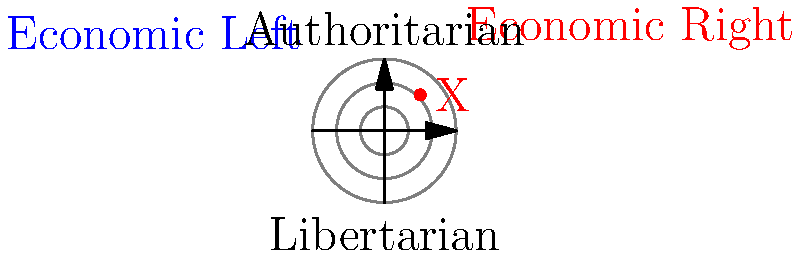In the political ideology spectrum represented by concentric circles in polar coordinates, a politician's stance is marked as point X. Which quadrant does this politician's ideology fall into, and what does it generally represent in terms of economic and social policies? To answer this question, we need to analyze the position of point X in the given polar coordinate system:

1. The diagram shows a political ideology spectrum with two axes:
   - Horizontal axis: Economic Left (negative) to Economic Right (positive)
   - Vertical axis: Libertarian (negative) to Authoritarian (positive)

2. The concentric circles represent different degrees of intensity, with the outer circles indicating stronger ideological leanings.

3. Point X is located in the upper-right quadrant of the diagram.

4. This quadrant represents:
   - Economically: Right-leaning (positive x-coordinate)
   - Socially: Authoritarian-leaning (positive y-coordinate)

5. The position of X suggests a moderate to strong leaning towards both right-wing economic policies and authoritarian social policies.

6. In Philippine context, this could represent a politician who favors:
   - Economic policies: Free-market capitalism, lower taxes, less government intervention in the economy
   - Social policies: Strong government control, traditional values, emphasis on law and order

Therefore, the politician's ideology falls into the upper-right quadrant, generally representing right-wing authoritarian views.
Answer: Upper-right quadrant; right-wing authoritarian 